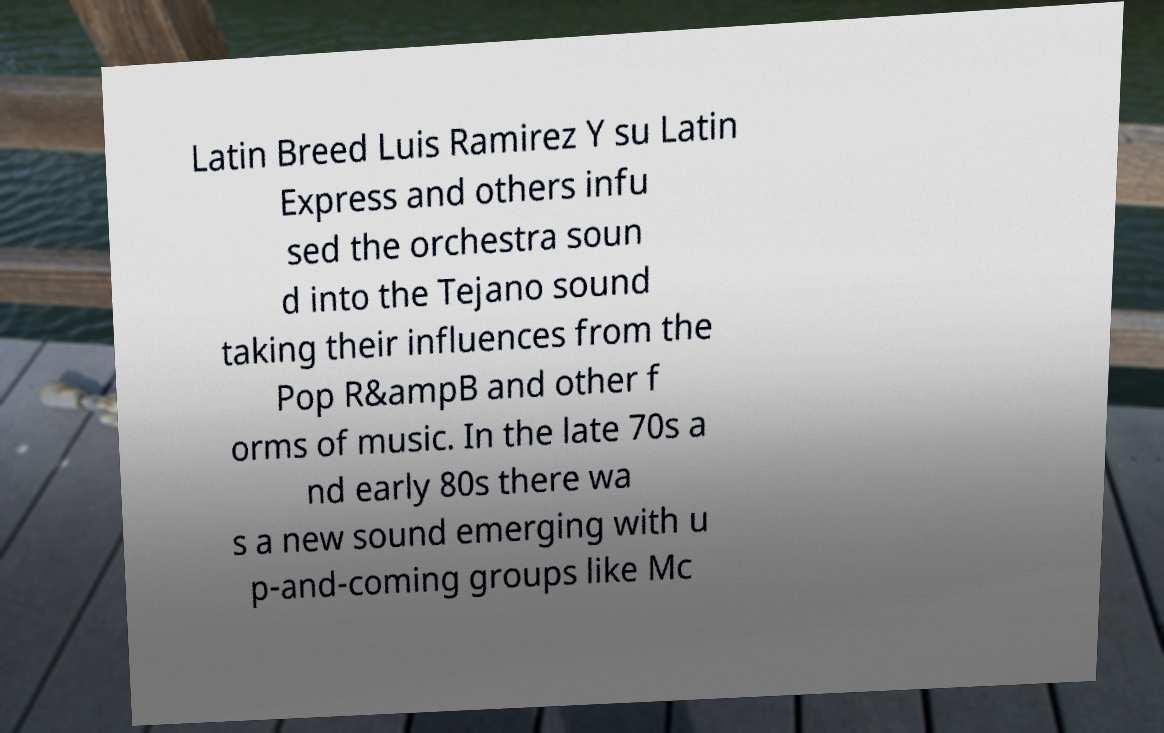For documentation purposes, I need the text within this image transcribed. Could you provide that? Latin Breed Luis Ramirez Y su Latin Express and others infu sed the orchestra soun d into the Tejano sound taking their influences from the Pop R&ampB and other f orms of music. In the late 70s a nd early 80s there wa s a new sound emerging with u p-and-coming groups like Mc 